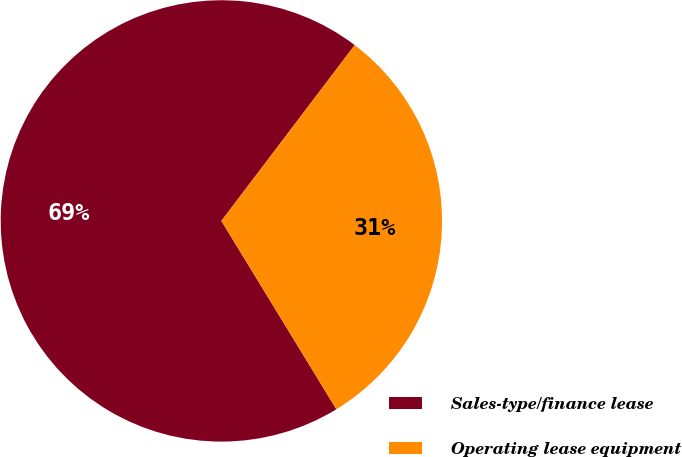Convert chart. <chart><loc_0><loc_0><loc_500><loc_500><pie_chart><fcel>Sales-type/finance lease<fcel>Operating lease equipment<nl><fcel>69.05%<fcel>30.95%<nl></chart> 